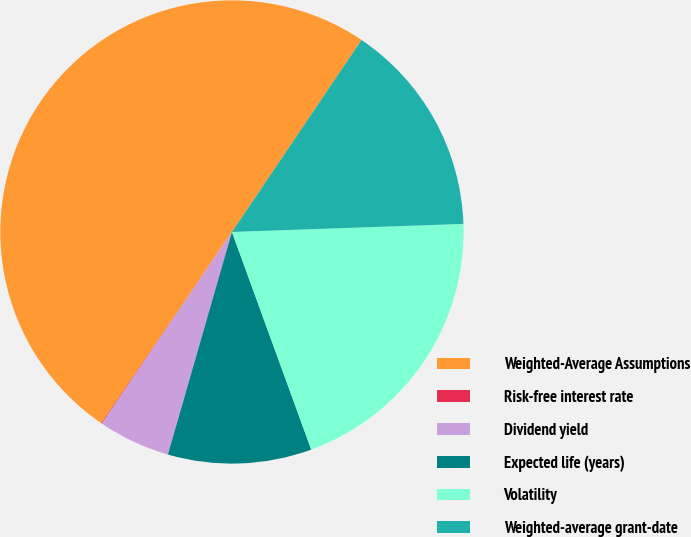<chart> <loc_0><loc_0><loc_500><loc_500><pie_chart><fcel>Weighted-Average Assumptions<fcel>Risk-free interest rate<fcel>Dividend yield<fcel>Expected life (years)<fcel>Volatility<fcel>Weighted-average grant-date<nl><fcel>49.91%<fcel>0.05%<fcel>5.03%<fcel>10.02%<fcel>19.99%<fcel>15.0%<nl></chart> 